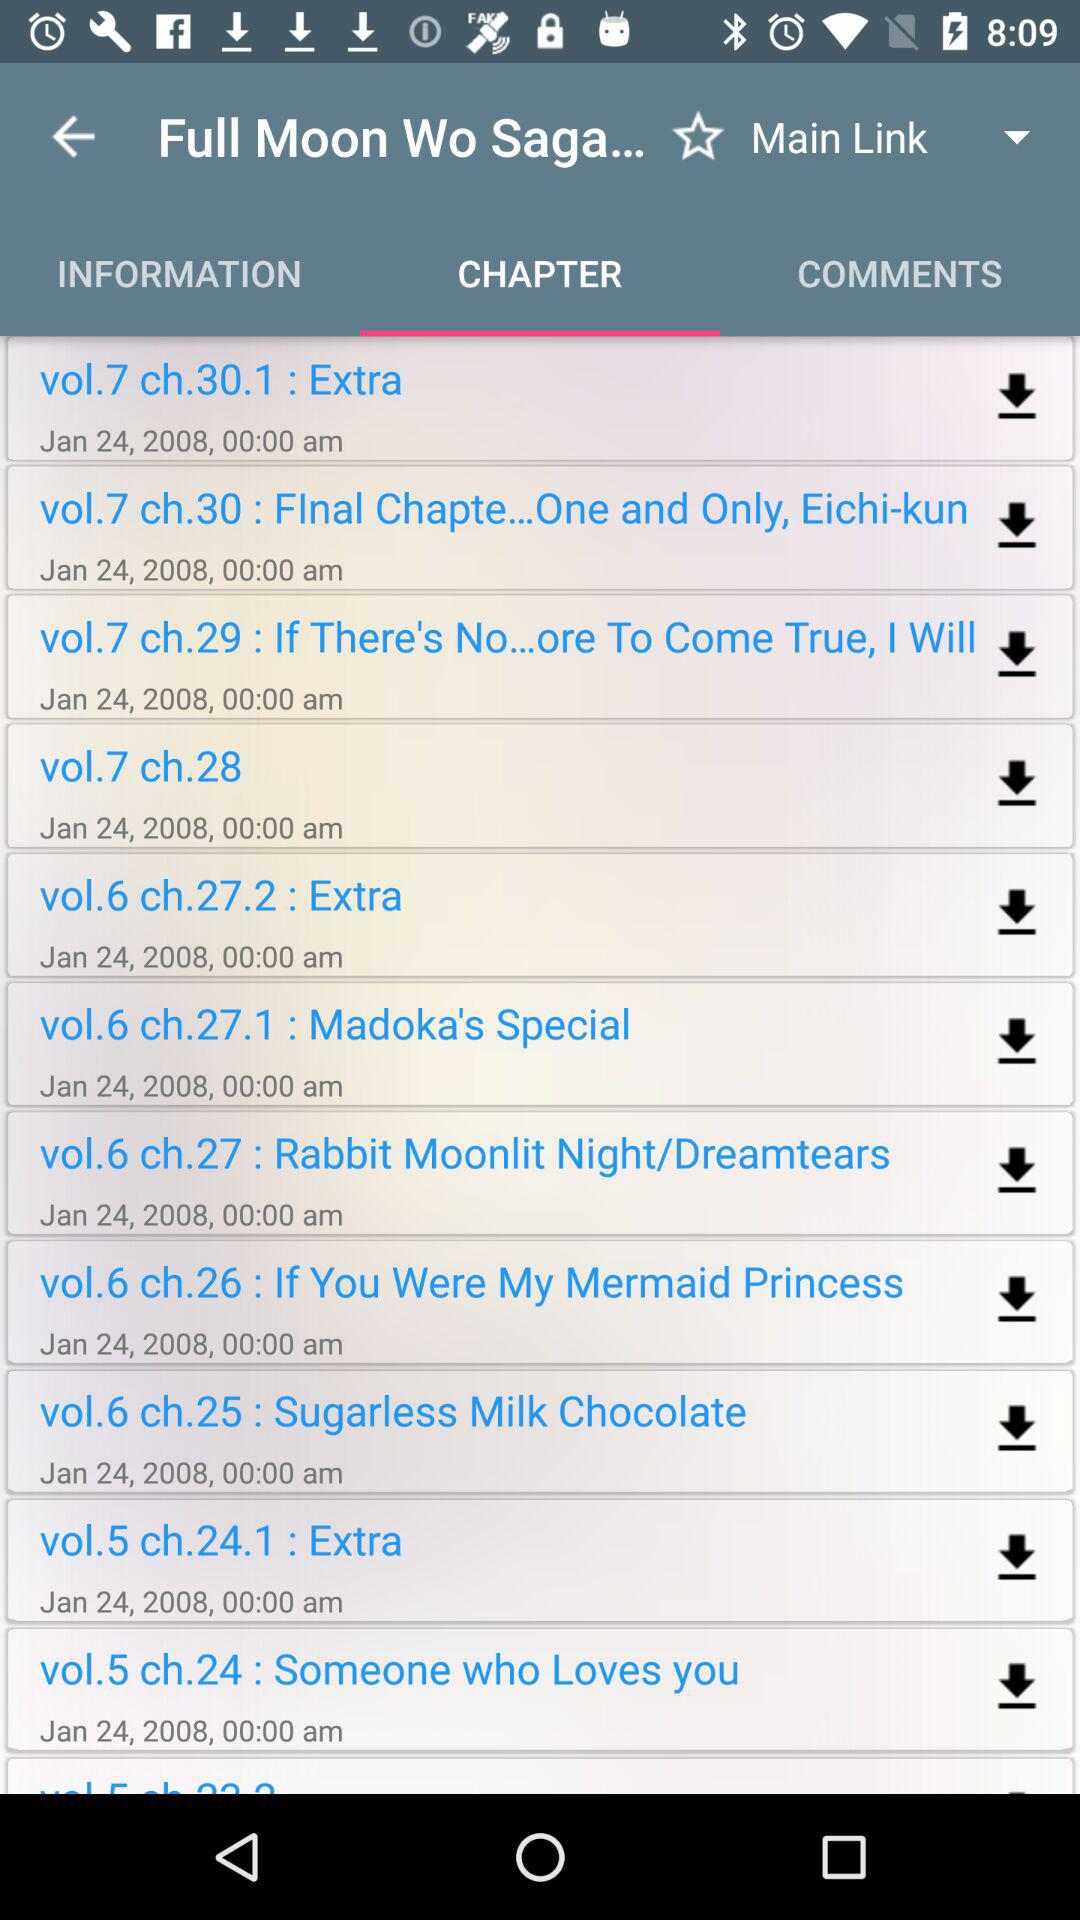When was the chapter of "vol.7 ch.30.1 : Extra" uploaded? The chapter "vol.7 ch.30.1 : Extra" was uploaded on January 24, 2008. 